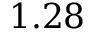<formula> <loc_0><loc_0><loc_500><loc_500>1 . 2 8</formula> 